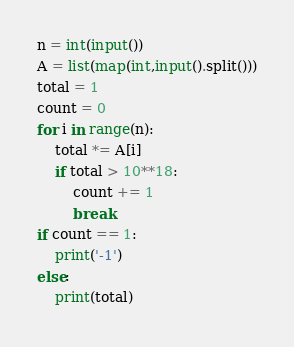<code> <loc_0><loc_0><loc_500><loc_500><_Python_>n = int(input())
A = list(map(int,input().split()))
total = 1
count = 0
for i in range(n):
    total *= A[i]
    if total > 10**18:
        count += 1
        break
if count == 1:
    print('-1')
else:
    print(total)</code> 